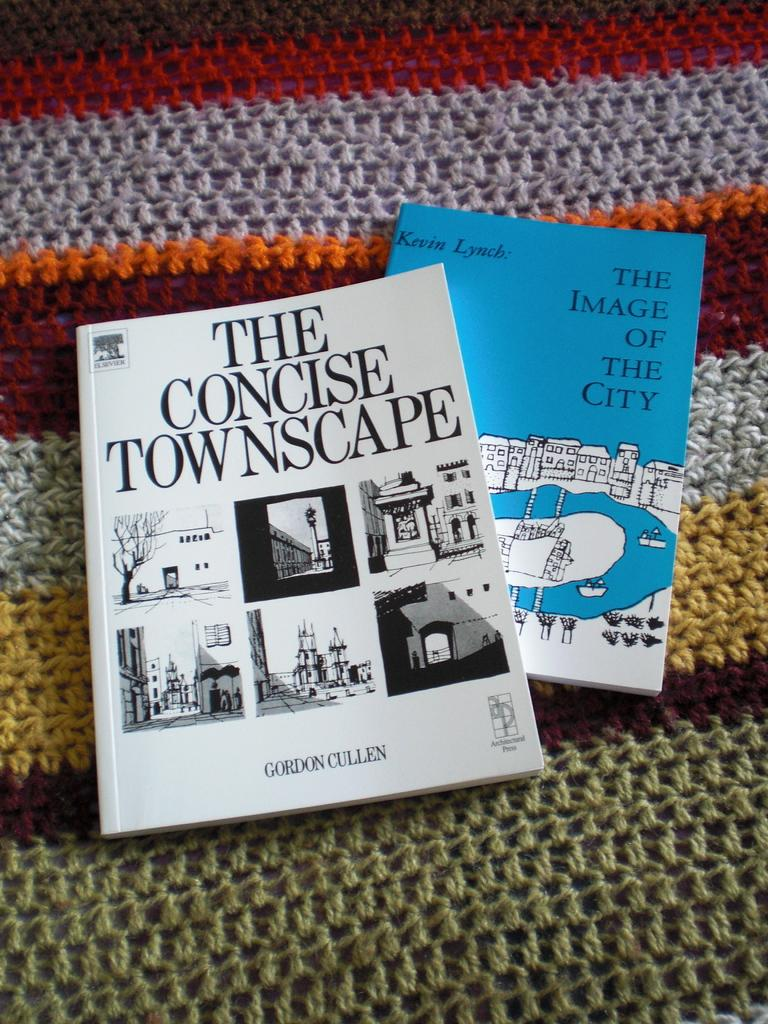<image>
Share a concise interpretation of the image provided. The second book in blue is called The image of the City. 